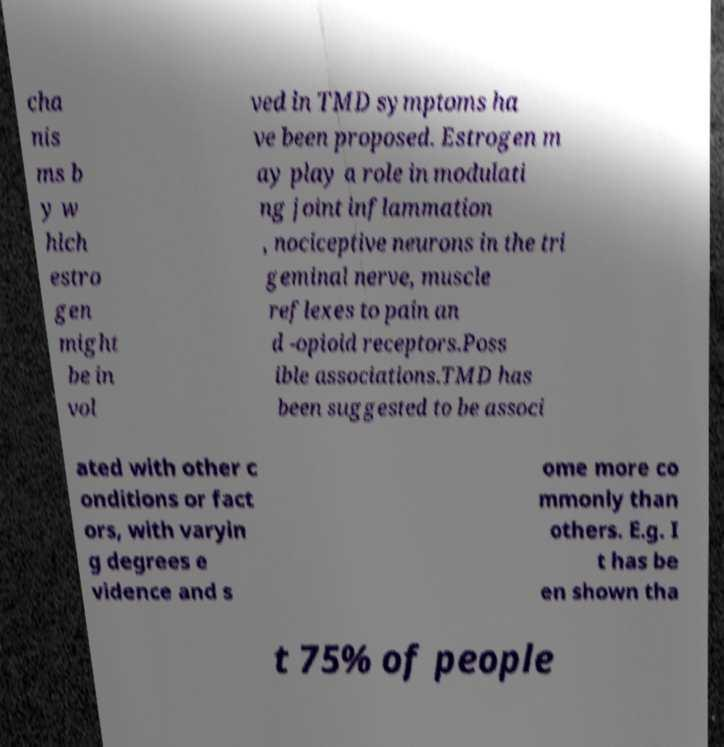Please identify and transcribe the text found in this image. cha nis ms b y w hich estro gen might be in vol ved in TMD symptoms ha ve been proposed. Estrogen m ay play a role in modulati ng joint inflammation , nociceptive neurons in the tri geminal nerve, muscle reflexes to pain an d -opioid receptors.Poss ible associations.TMD has been suggested to be associ ated with other c onditions or fact ors, with varyin g degrees e vidence and s ome more co mmonly than others. E.g. I t has be en shown tha t 75% of people 